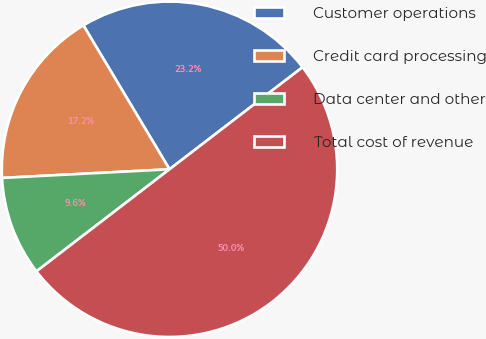<chart> <loc_0><loc_0><loc_500><loc_500><pie_chart><fcel>Customer operations<fcel>Credit card processing<fcel>Data center and other<fcel>Total cost of revenue<nl><fcel>23.17%<fcel>17.24%<fcel>9.59%<fcel>50.0%<nl></chart> 